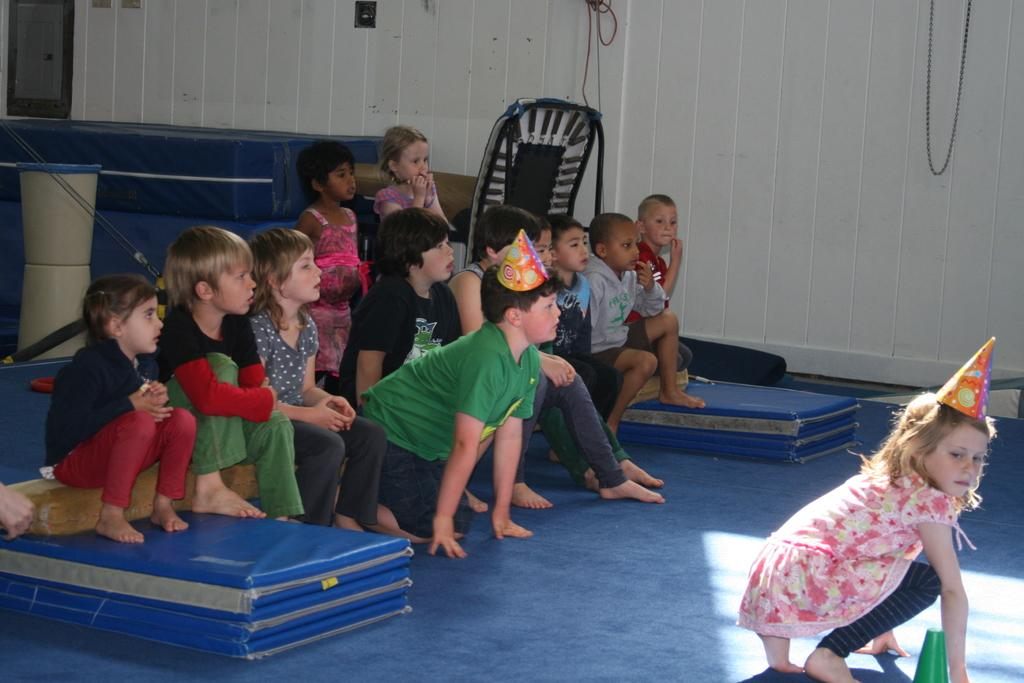What can be seen in the background of the image? There is a wall in the background of the image. Who is present in the image? There are children in the image. What are some of the children wearing? Some of the children are wearing caps. What else can be seen in the image besides the children? There are objects visible in the image. What color is the floor carpet in the image? The floor carpet in the image is blue. What type of authority figure can be seen in the image? There is no authority figure present in the image. How much sugar is visible in the image? There is no sugar visible in the image. 